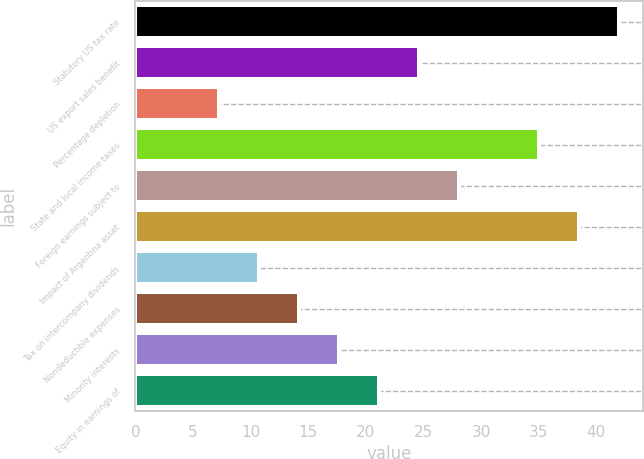<chart> <loc_0><loc_0><loc_500><loc_500><bar_chart><fcel>Statutory US tax rate<fcel>US export sales benefit<fcel>Percentage depletion<fcel>State and local income taxes<fcel>Foreign earnings subject to<fcel>Impact of Argentina asset<fcel>Tax on intercompany dividends<fcel>Nondeductible expenses<fcel>Minority interests<fcel>Equity in earnings of<nl><fcel>41.94<fcel>24.61<fcel>7.28<fcel>35<fcel>28.07<fcel>38.47<fcel>10.75<fcel>14.21<fcel>17.68<fcel>21.14<nl></chart> 